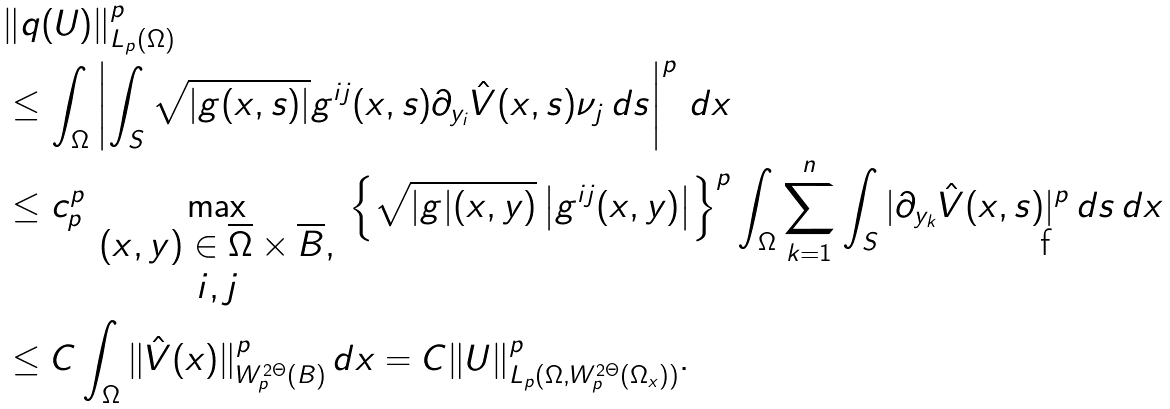Convert formula to latex. <formula><loc_0><loc_0><loc_500><loc_500>& \| q ( U ) \| ^ { p } _ { L _ { p } ( \Omega ) } \\ & \leq \int _ { \Omega } \left | \int _ { S } \sqrt { | g ( x , s ) | } g ^ { i j } ( x , s ) \partial _ { y _ { i } } \hat { V } ( x , s ) \nu _ { j } \, d s \right | ^ { p } \, d x \\ & \leq c ^ { p } _ { p } \max _ { \begin{array} { c } ( x , y ) \in \overline { \Omega } \times \overline { B } , \\ i , j \end{array} } \left \{ \sqrt { | g | ( x , y ) } \left | g ^ { i j } ( x , y ) \right | \right \} ^ { p } \int _ { \Omega } \sum _ { k = 1 } ^ { n } \int _ { S } | \partial _ { y _ { k } } \hat { V } ( x , s ) | ^ { p } \, d s \, d x \\ & \leq C \int _ { \Omega } \| \hat { V } ( x ) \| ^ { p } _ { W _ { p } ^ { 2 \Theta } ( B ) } \, d x = C \| U \| ^ { p } _ { L _ { p } ( \Omega , W _ { p } ^ { 2 \Theta } ( \Omega _ { x } ) ) } .</formula> 